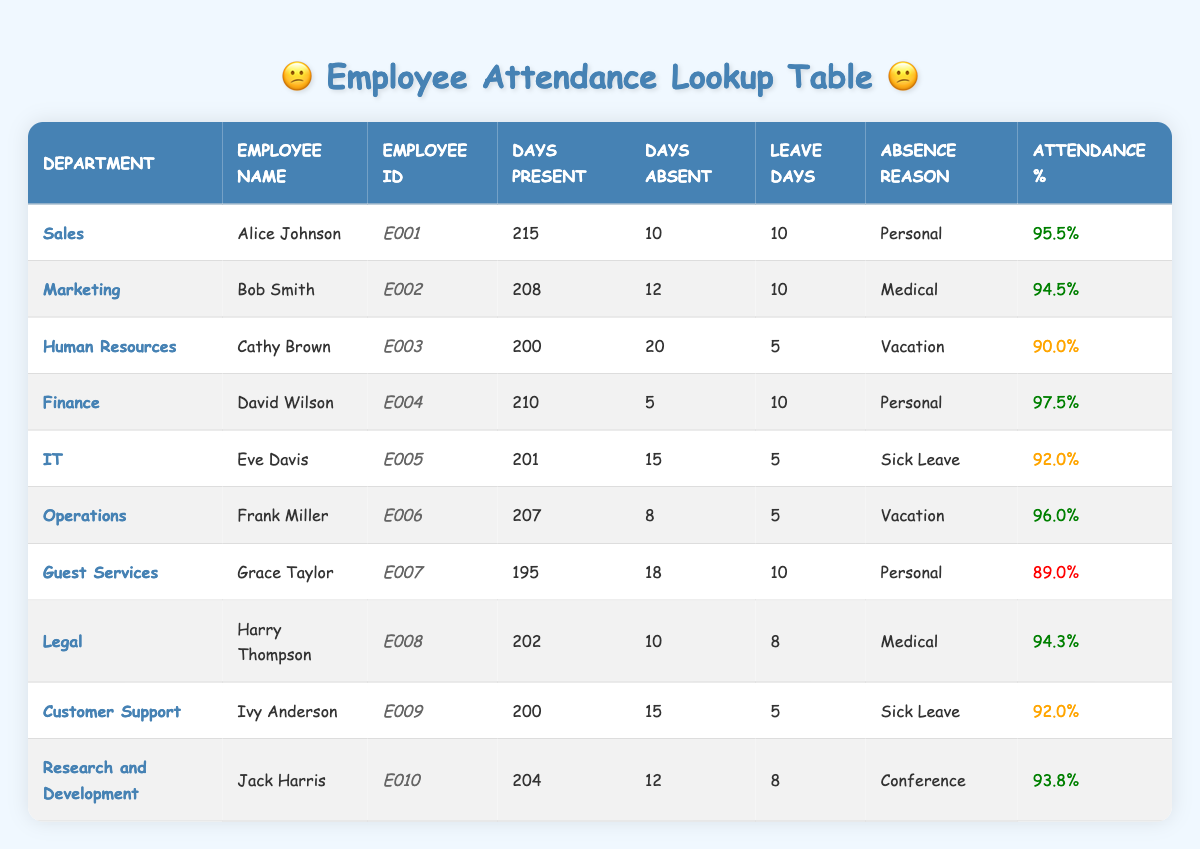What is the attendance percentage of Alice Johnson? The attendance percentage is listed in the table under the column "Attendance %". For Alice Johnson, the attendance percentage is shown as 95.5%.
Answer: 95.5% Which employee has the highest number of days present? By examining the "Days Present" column, David Wilson has the highest number with 210 days present, followed closely by Alice Johnson with 215 days.
Answer: Alice Johnson What is the total number of leave days taken by all employees in the Finance and Human Resources departments? First, we need to look at the leave days for both departments. Finance has David Wilson with 10 leave days, and Human Resources has Cathy Brown with 5 leave days. Summing these gives 10 + 5 = 15.
Answer: 15 Are there any employees in the Guest Services department who have an attendance percentage below 90%? The attendance percentage for Grace Taylor in Guest Services is recorded as 89.0%, which is indeed below 90%. Therefore, the answer is yes.
Answer: Yes What is the average attendance percentage for all employees listed? To find the average, we add all the attendance percentages: (95.5 + 94.5 + 90.0 + 97.5 + 92.0 + 96.0 + 89.0 + 94.3 + 92.0 + 93.8) =  919.6. Then we divide that sum by the number of employees, which is 10, giving us 919.6 / 10 = 91.96.
Answer: 91.96 Which department had the most leave days taken? First, we find the total leave days for each department from the "Leave Days" column. Sales (10), Marketing (10), Human Resources (5), Finance (10), IT (5), Operations (5), Guest Services (10), Legal (8), Customer Support (5), and Research and Development (8). Sales, Marketing, Finance, and Guest Services all have the highest total which is 10 leave days.
Answer: Sales, Marketing, Finance, Guest Services How many employees in the IT and Customer Support departments had a "Sick Leave" absence reason? In the table, Eve Davis from IT has "Sick Leave" as her reason for absence and so does Ivy Anderson from Customer Support. Thus, there are two employees with that specific absence reason.
Answer: 2 Which department had the lowest attendance percentage and what was it? Looking through the attendance percentages, Guest Services with Grace Taylor has the lowest at 89.0%. This is the value indicating the lowest attendance in the table.
Answer: Guest Services, 89.0% 